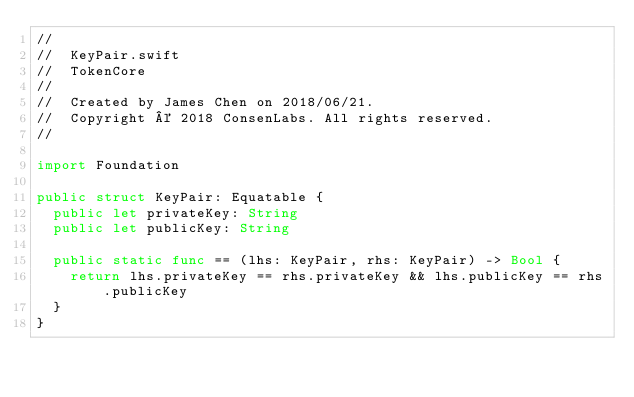<code> <loc_0><loc_0><loc_500><loc_500><_Swift_>//
//  KeyPair.swift
//  TokenCore
//
//  Created by James Chen on 2018/06/21.
//  Copyright © 2018 ConsenLabs. All rights reserved.
//

import Foundation

public struct KeyPair: Equatable {
  public let privateKey: String
  public let publicKey: String

  public static func == (lhs: KeyPair, rhs: KeyPair) -> Bool {
    return lhs.privateKey == rhs.privateKey && lhs.publicKey == rhs.publicKey
  }
}
</code> 